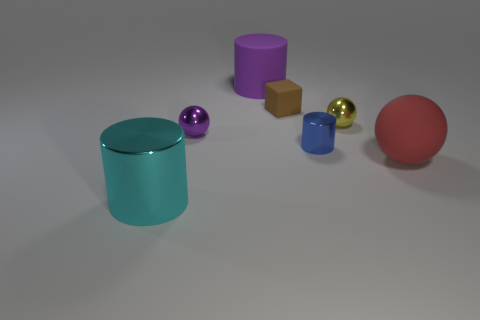The thing that is the same color as the rubber cylinder is what shape?
Your answer should be very brief. Sphere. Are there any other things of the same color as the rubber cylinder?
Provide a short and direct response. Yes. Does the big cylinder to the right of the small purple shiny object have the same color as the ball on the left side of the blue metal cylinder?
Your response must be concise. Yes. What material is the yellow ball that is the same size as the purple sphere?
Keep it short and to the point. Metal. What size is the metallic cylinder right of the metal thing that is in front of the matte thing that is on the right side of the yellow object?
Offer a terse response. Small. How many other things are there of the same material as the large red object?
Give a very brief answer. 2. There is a shiny cylinder behind the large metal object; what size is it?
Provide a short and direct response. Small. How many things are both left of the purple rubber cylinder and behind the red matte sphere?
Your answer should be very brief. 1. The purple thing behind the tiny ball that is left of the purple matte cylinder is made of what material?
Your response must be concise. Rubber. What is the material of the large cyan thing that is the same shape as the large purple object?
Offer a terse response. Metal. 